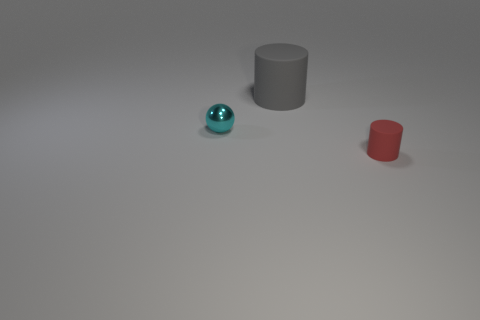Add 2 small metallic objects. How many objects exist? 5 Subtract all gray cylinders. How many cylinders are left? 1 Subtract all cylinders. How many objects are left? 1 Subtract all brown spheres. How many red cylinders are left? 1 Subtract all tiny red cylinders. Subtract all large cyan objects. How many objects are left? 2 Add 3 matte cylinders. How many matte cylinders are left? 5 Add 3 gray rubber objects. How many gray rubber objects exist? 4 Subtract 0 yellow blocks. How many objects are left? 3 Subtract 1 spheres. How many spheres are left? 0 Subtract all gray balls. Subtract all yellow cubes. How many balls are left? 1 